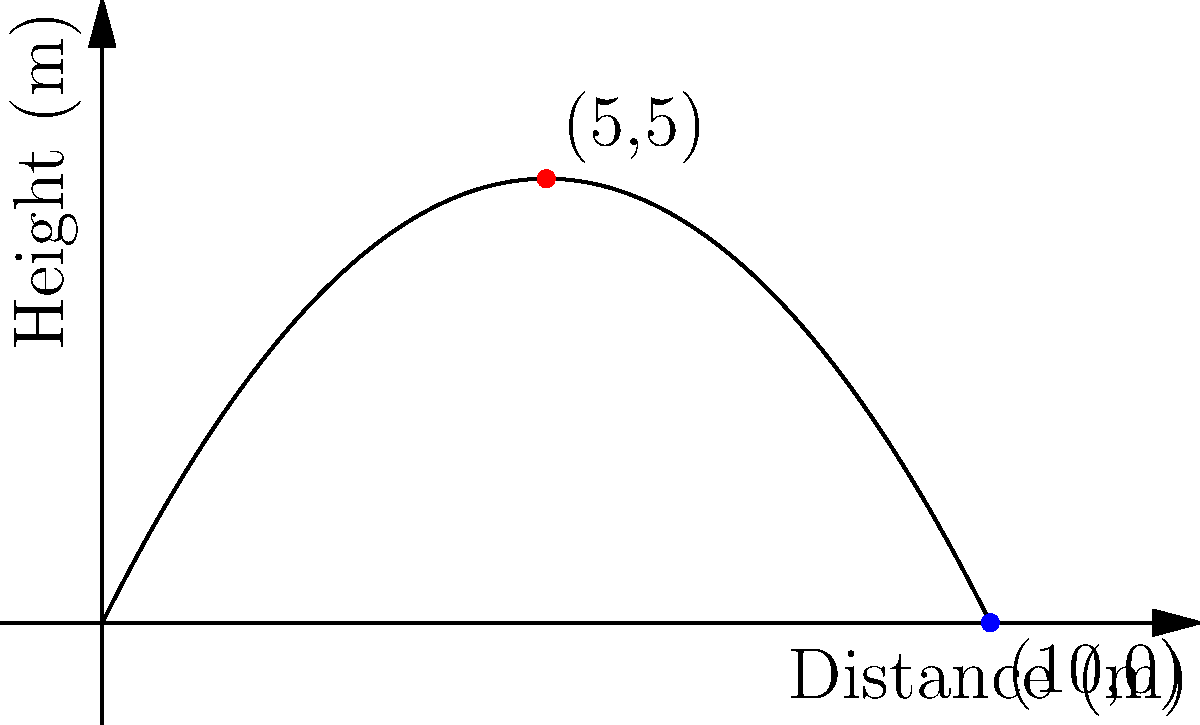During a crucial match at The Shay, an FC Halifax Town player takes a free kick. The trajectory of the ball can be modeled by the equation $h(x) = -0.2x^2 + 2x$, where $h$ is the height of the ball in meters and $x$ is the horizontal distance in meters. What is the maximum height reached by the ball, and at what horizontal distance does this occur? To find the maximum height of the ball and the horizontal distance at which it occurs, we need to follow these steps:

1) The maximum point of a parabola occurs at the vertex. For a parabola in the form $f(x) = ax^2 + bx + c$, the x-coordinate of the vertex is given by $x = -\frac{b}{2a}$.

2) In our equation $h(x) = -0.2x^2 + 2x$, we have $a = -0.2$ and $b = 2$.

3) Substituting these values:
   $x = -\frac{2}{2(-0.2)} = -\frac{2}{-0.4} = 5$ meters

4) To find the maximum height, we substitute this x-value back into the original equation:
   $h(5) = -0.2(5^2) + 2(5)$
   $= -0.2(25) + 10$
   $= -5 + 10 = 5$ meters

Therefore, the ball reaches its maximum height of 5 meters at a horizontal distance of 5 meters from the kick point.
Answer: Maximum height: 5 meters; Horizontal distance: 5 meters 